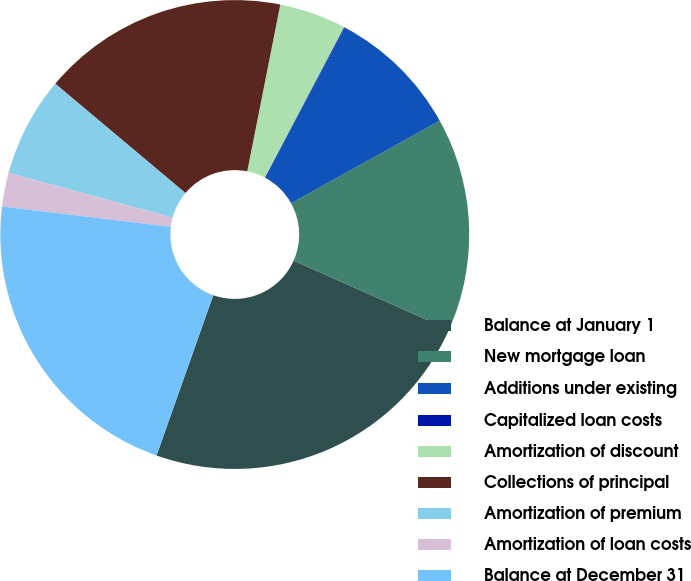<chart> <loc_0><loc_0><loc_500><loc_500><pie_chart><fcel>Balance at January 1<fcel>New mortgage loan<fcel>Additions under existing<fcel>Capitalized loan costs<fcel>Amortization of discount<fcel>Collections of principal<fcel>Amortization of premium<fcel>Amortization of loan costs<fcel>Balance at December 31<nl><fcel>23.76%<fcel>14.72%<fcel>9.15%<fcel>0.06%<fcel>4.61%<fcel>16.99%<fcel>6.88%<fcel>2.33%<fcel>21.49%<nl></chart> 